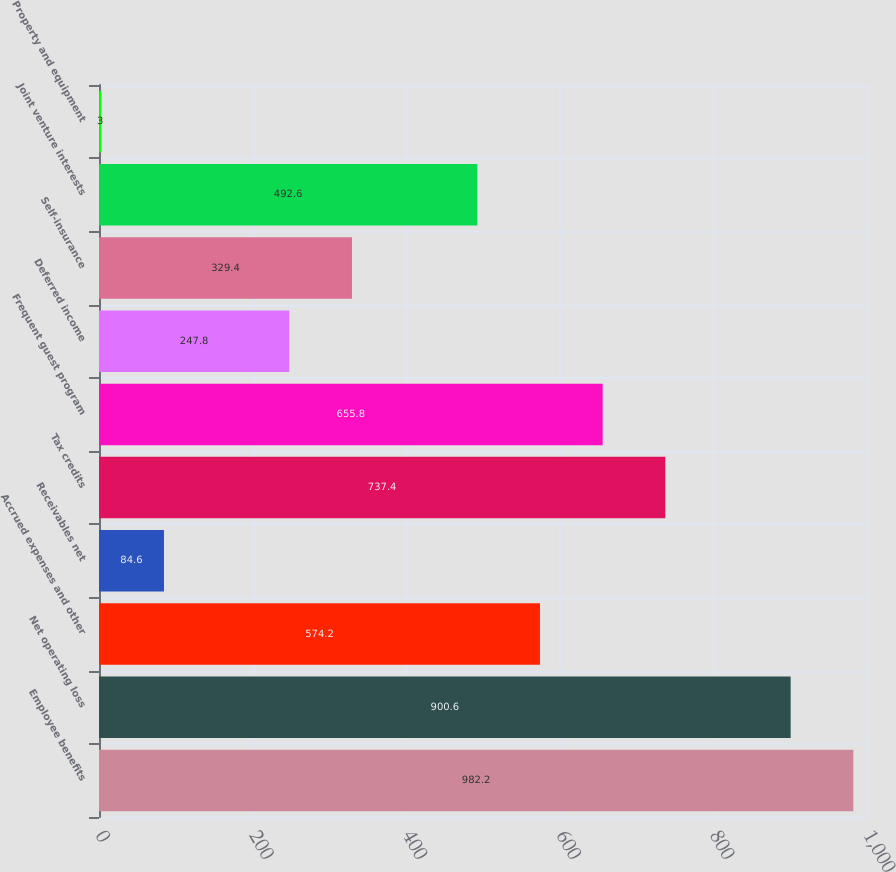Convert chart to OTSL. <chart><loc_0><loc_0><loc_500><loc_500><bar_chart><fcel>Employee benefits<fcel>Net operating loss<fcel>Accrued expenses and other<fcel>Receivables net<fcel>Tax credits<fcel>Frequent guest program<fcel>Deferred income<fcel>Self-insurance<fcel>Joint venture interests<fcel>Property and equipment<nl><fcel>982.2<fcel>900.6<fcel>574.2<fcel>84.6<fcel>737.4<fcel>655.8<fcel>247.8<fcel>329.4<fcel>492.6<fcel>3<nl></chart> 